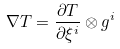Convert formula to latex. <formula><loc_0><loc_0><loc_500><loc_500>\nabla T = \frac { \partial T } { \partial \xi ^ { i } } \otimes g ^ { i }</formula> 